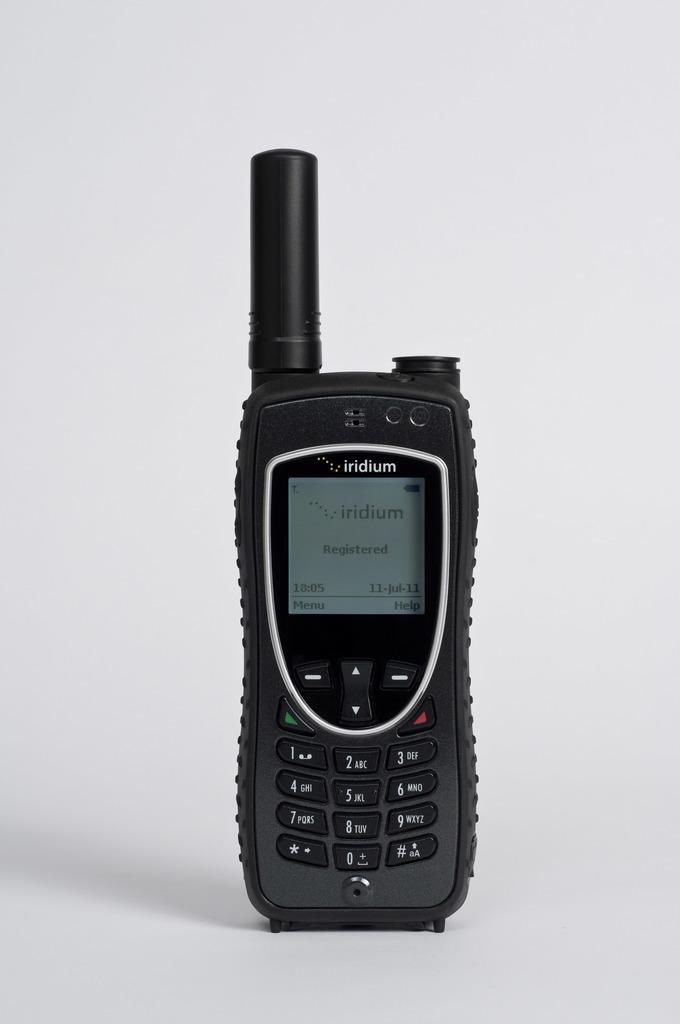What is the color of the background in the image? The background of the image is gray. What electronic device can be seen in the image? There is a mobile phone in the image. Where is the mobile phone located in the image? The mobile phone is on a surface. What is the color of the mobile phone? The mobile phone is black in color. What type of reward is being given to the bears in the image? There are no bears present in the image, and therefore no rewards are being given. 